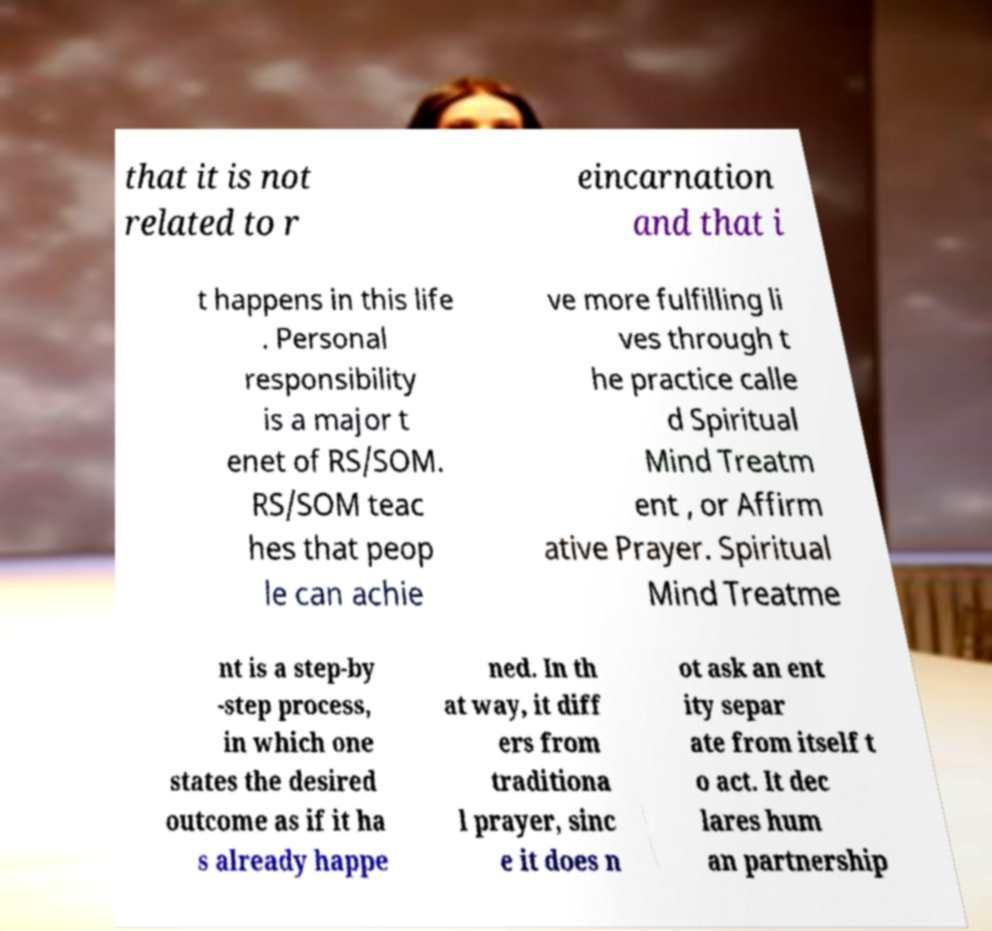Please identify and transcribe the text found in this image. that it is not related to r eincarnation and that i t happens in this life . Personal responsibility is a major t enet of RS/SOM. RS/SOM teac hes that peop le can achie ve more fulfilling li ves through t he practice calle d Spiritual Mind Treatm ent , or Affirm ative Prayer. Spiritual Mind Treatme nt is a step-by -step process, in which one states the desired outcome as if it ha s already happe ned. In th at way, it diff ers from traditiona l prayer, sinc e it does n ot ask an ent ity separ ate from itself t o act. It dec lares hum an partnership 